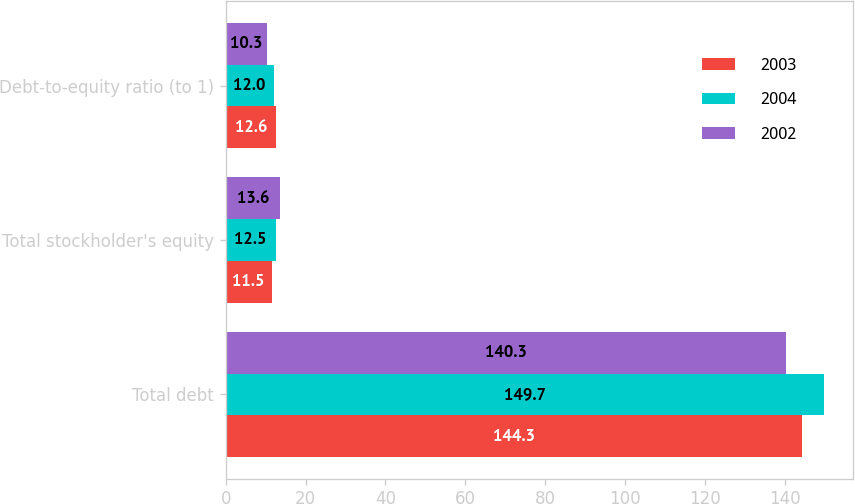Convert chart. <chart><loc_0><loc_0><loc_500><loc_500><stacked_bar_chart><ecel><fcel>Total debt<fcel>Total stockholder's equity<fcel>Debt-to-equity ratio (to 1)<nl><fcel>2003<fcel>144.3<fcel>11.5<fcel>12.6<nl><fcel>2004<fcel>149.7<fcel>12.5<fcel>12<nl><fcel>2002<fcel>140.3<fcel>13.6<fcel>10.3<nl></chart> 